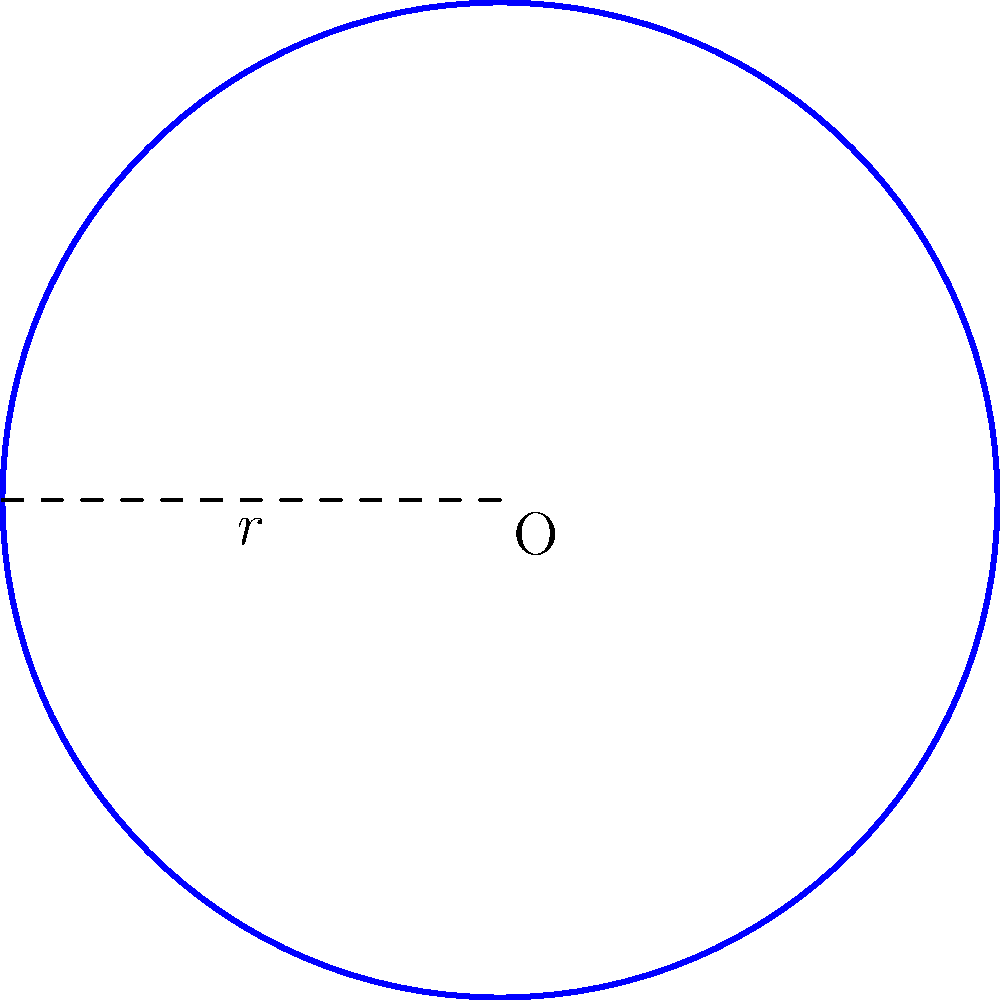In honor of your days playing for the Saskatoon Wild, imagine a circular ringette rink with a radius of 12.5 meters. What is the total area of this rink in square meters? Round your answer to the nearest whole number. To find the area of a circular ringette rink, we can use the formula for the area of a circle:

$$A = \pi r^2$$

Where:
$A$ = area of the circle
$\pi$ = pi (approximately 3.14159)
$r$ = radius of the circle

Given:
Radius ($r$) = 12.5 meters

Step 1: Substitute the values into the formula
$$A = \pi (12.5)^2$$

Step 2: Calculate the square of the radius
$$A = \pi (156.25)$$

Step 3: Multiply by $\pi$
$$A = 491.07 \text{ m}^2$$

Step 4: Round to the nearest whole number
$$A \approx 491 \text{ m}^2$$
Answer: 491 m² 